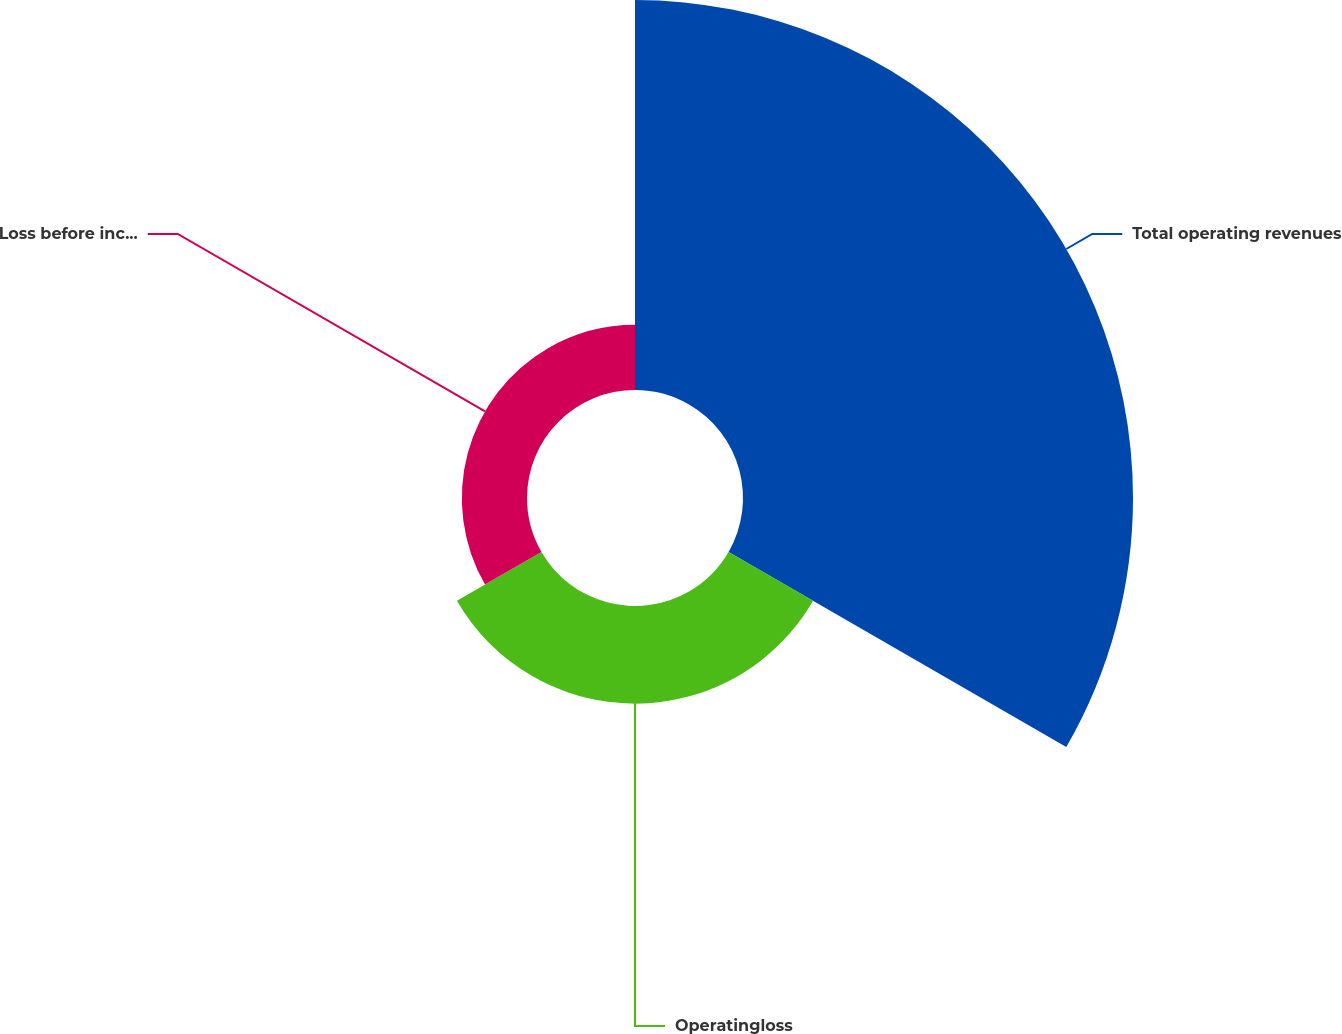Convert chart to OTSL. <chart><loc_0><loc_0><loc_500><loc_500><pie_chart><fcel>Total operating revenues<fcel>Operatingloss<fcel>Loss before income taxes and<nl><fcel>70.55%<fcel>17.66%<fcel>11.79%<nl></chart> 